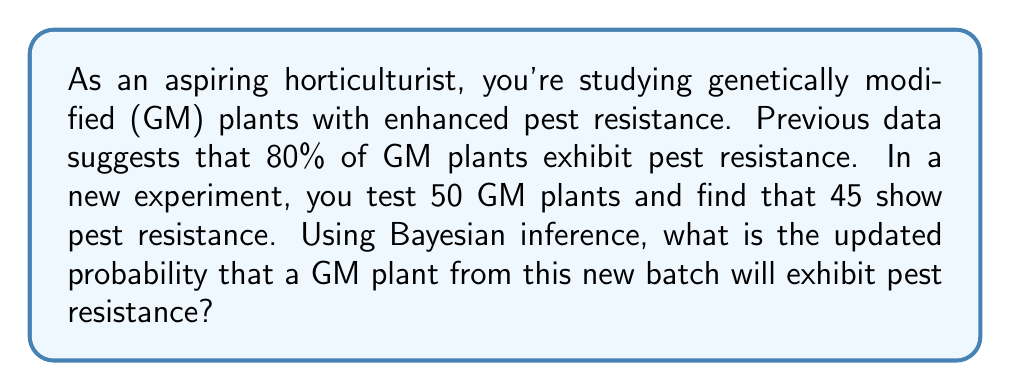What is the answer to this math problem? Let's approach this step-by-step using Bayesian inference:

1) Define our variables:
   $\theta$ = probability of pest resistance
   $D$ = observed data (45 out of 50 plants show resistance)

2) We need to calculate $P(\theta|D)$, the posterior probability.

3) Bayes' theorem states:
   $$P(\theta|D) = \frac{P(D|\theta) \cdot P(\theta)}{P(D)}$$

4) Prior probability $P(\theta)$:
   Based on previous data, $P(\theta) = 0.80$

5) Likelihood $P(D|\theta)$:
   This follows a binomial distribution:
   $$P(D|\theta) = \binom{50}{45} \theta^{45} (1-\theta)^{5}$$

6) Evidence $P(D)$:
   This is a normalizing constant. We can calculate it as:
   $$P(D) = P(D|\theta) \cdot P(\theta) + P(D|\text{not }\theta) \cdot P(\text{not }\theta)$$
   $$= \binom{50}{45} 0.80^{45} 0.20^{5} \cdot 0.80 + \binom{50}{45} 0.20^{45} 0.80^{5} \cdot 0.20$$

7) Putting it all together:
   $$P(\theta|D) = \frac{\binom{50}{45} 0.80^{45} 0.20^{5} \cdot 0.80}{\binom{50}{45} 0.80^{45} 0.20^{5} \cdot 0.80 + \binom{50}{45} 0.20^{45} 0.80^{5} \cdot 0.20}$$

8) Simplify and calculate:
   $$P(\theta|D) = \frac{0.80^{46} \cdot 0.20^{5}}{0.80^{46} \cdot 0.20^{5} + 0.20^{46} \cdot 0.80^{6}} \approx 0.9998$$

Therefore, the updated probability that a GM plant from this new batch will exhibit pest resistance is approximately 0.9998 or 99.98%.
Answer: 0.9998 